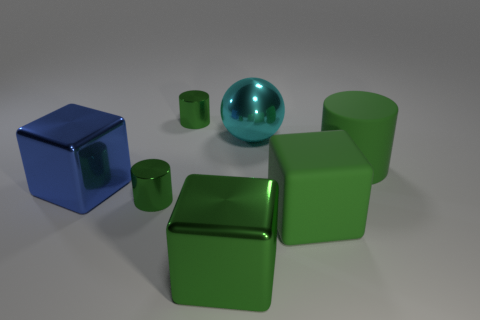Are there any purple cylinders of the same size as the blue thing?
Give a very brief answer. No. What number of things are either tiny green shiny things that are in front of the blue block or big things behind the big green matte block?
Give a very brief answer. 4. There is a cube left of the green cube to the left of the green matte cube; what is its color?
Keep it short and to the point. Blue. There is a big object that is the same material as the large green cylinder; what color is it?
Offer a terse response. Green. How many big matte things have the same color as the rubber block?
Offer a very short reply. 1. How many objects are either large balls or big green objects?
Give a very brief answer. 4. There is a cyan object that is the same size as the blue shiny thing; what shape is it?
Offer a very short reply. Sphere. How many things are in front of the blue metallic block and on the right side of the shiny sphere?
Provide a short and direct response. 1. There is a block that is left of the big green metal object; what is it made of?
Your answer should be very brief. Metal. Do the metal cylinder in front of the large green rubber cylinder and the green metal cylinder that is behind the large blue cube have the same size?
Your answer should be compact. Yes. 